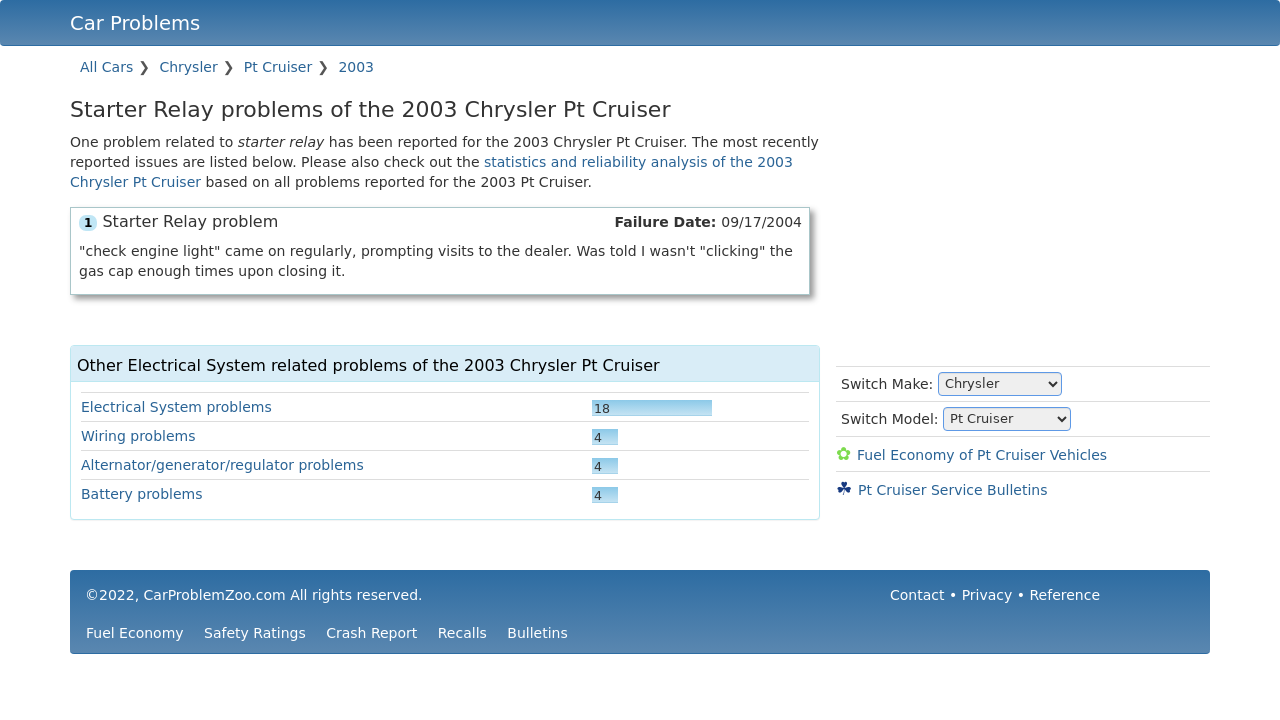What's the procedure for constructing this website from scratch with HTML? To construct a website like the one shown in the image, which details car problems for different makes and models, you would start by creating a basic HTML structure. This includes setting up the DOCTYPE, html, head, and body tags. Inside the body, use div elements to create sections such as the header, main content area, and footer. You would then add a navigation bar, possibly using the nav element with linked a tags for different car models and years. For the content area, use tables or list elements to display the different problems and their descriptions. Finally, remember to style your website using CSS to match the clean and professional layout shown in the image. 